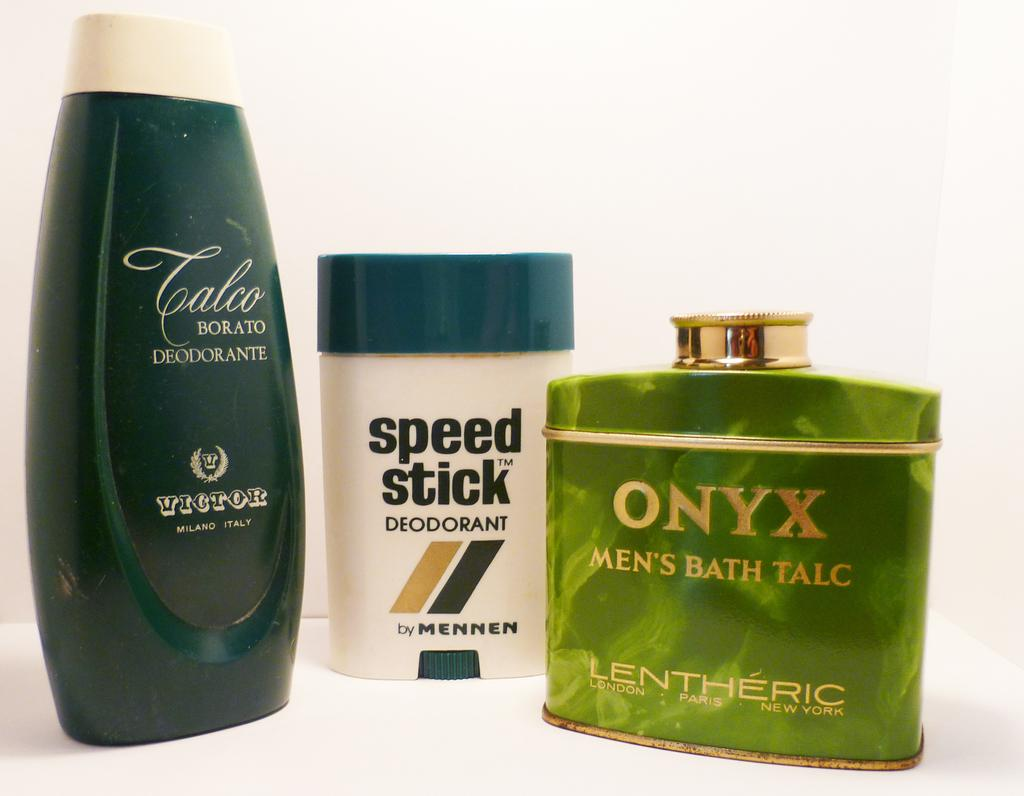<image>
Summarize the visual content of the image. three bottles of men's care products with the middle being speed stick deodorant 